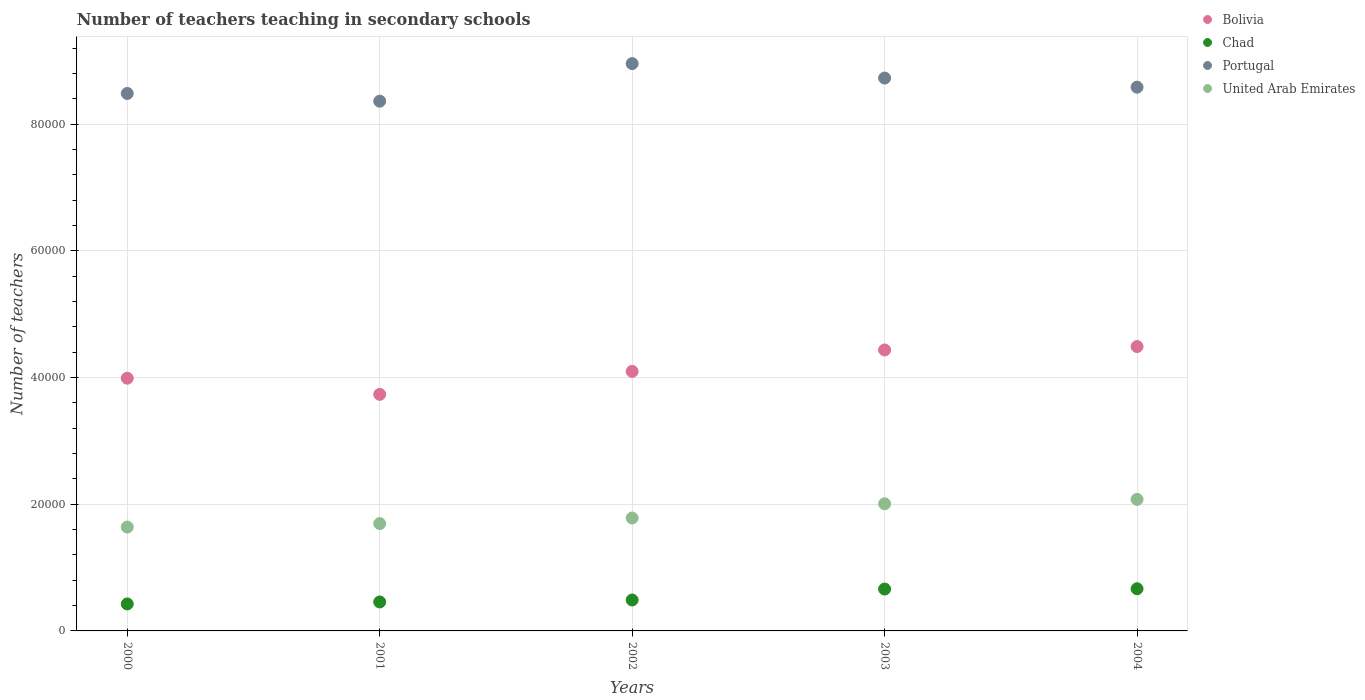How many different coloured dotlines are there?
Give a very brief answer. 4. Is the number of dotlines equal to the number of legend labels?
Ensure brevity in your answer.  Yes. What is the number of teachers teaching in secondary schools in United Arab Emirates in 2003?
Make the answer very short. 2.01e+04. Across all years, what is the maximum number of teachers teaching in secondary schools in United Arab Emirates?
Offer a very short reply. 2.08e+04. Across all years, what is the minimum number of teachers teaching in secondary schools in Chad?
Provide a short and direct response. 4260. In which year was the number of teachers teaching in secondary schools in Bolivia maximum?
Offer a terse response. 2004. In which year was the number of teachers teaching in secondary schools in Bolivia minimum?
Give a very brief answer. 2001. What is the total number of teachers teaching in secondary schools in Chad in the graph?
Ensure brevity in your answer.  2.70e+04. What is the difference between the number of teachers teaching in secondary schools in United Arab Emirates in 2000 and that in 2001?
Give a very brief answer. -551. What is the difference between the number of teachers teaching in secondary schools in United Arab Emirates in 2002 and the number of teachers teaching in secondary schools in Chad in 2000?
Offer a terse response. 1.36e+04. What is the average number of teachers teaching in secondary schools in Bolivia per year?
Offer a very short reply. 4.15e+04. In the year 2003, what is the difference between the number of teachers teaching in secondary schools in Chad and number of teachers teaching in secondary schools in Bolivia?
Offer a very short reply. -3.78e+04. In how many years, is the number of teachers teaching in secondary schools in United Arab Emirates greater than 64000?
Ensure brevity in your answer.  0. What is the ratio of the number of teachers teaching in secondary schools in Portugal in 2001 to that in 2002?
Keep it short and to the point. 0.93. What is the difference between the highest and the second highest number of teachers teaching in secondary schools in Bolivia?
Your answer should be very brief. 539. What is the difference between the highest and the lowest number of teachers teaching in secondary schools in Chad?
Ensure brevity in your answer.  2401. Is it the case that in every year, the sum of the number of teachers teaching in secondary schools in Bolivia and number of teachers teaching in secondary schools in Chad  is greater than the sum of number of teachers teaching in secondary schools in Portugal and number of teachers teaching in secondary schools in United Arab Emirates?
Give a very brief answer. No. Is it the case that in every year, the sum of the number of teachers teaching in secondary schools in Chad and number of teachers teaching in secondary schools in Bolivia  is greater than the number of teachers teaching in secondary schools in United Arab Emirates?
Provide a short and direct response. Yes. Is the number of teachers teaching in secondary schools in United Arab Emirates strictly greater than the number of teachers teaching in secondary schools in Bolivia over the years?
Your answer should be compact. No. How many dotlines are there?
Make the answer very short. 4. Are the values on the major ticks of Y-axis written in scientific E-notation?
Make the answer very short. No. Does the graph contain any zero values?
Make the answer very short. No. What is the title of the graph?
Your answer should be compact. Number of teachers teaching in secondary schools. Does "Curacao" appear as one of the legend labels in the graph?
Provide a short and direct response. No. What is the label or title of the X-axis?
Offer a very short reply. Years. What is the label or title of the Y-axis?
Your answer should be very brief. Number of teachers. What is the Number of teachers of Bolivia in 2000?
Offer a very short reply. 3.99e+04. What is the Number of teachers in Chad in 2000?
Make the answer very short. 4260. What is the Number of teachers in Portugal in 2000?
Provide a short and direct response. 8.49e+04. What is the Number of teachers of United Arab Emirates in 2000?
Ensure brevity in your answer.  1.64e+04. What is the Number of teachers in Bolivia in 2001?
Provide a succinct answer. 3.74e+04. What is the Number of teachers of Chad in 2001?
Offer a very short reply. 4572. What is the Number of teachers of Portugal in 2001?
Your answer should be very brief. 8.37e+04. What is the Number of teachers of United Arab Emirates in 2001?
Your answer should be compact. 1.70e+04. What is the Number of teachers in Bolivia in 2002?
Ensure brevity in your answer.  4.10e+04. What is the Number of teachers in Chad in 2002?
Your response must be concise. 4883. What is the Number of teachers in Portugal in 2002?
Make the answer very short. 8.96e+04. What is the Number of teachers of United Arab Emirates in 2002?
Keep it short and to the point. 1.78e+04. What is the Number of teachers in Bolivia in 2003?
Your answer should be very brief. 4.44e+04. What is the Number of teachers in Chad in 2003?
Give a very brief answer. 6613. What is the Number of teachers of Portugal in 2003?
Keep it short and to the point. 8.73e+04. What is the Number of teachers in United Arab Emirates in 2003?
Your response must be concise. 2.01e+04. What is the Number of teachers of Bolivia in 2004?
Make the answer very short. 4.49e+04. What is the Number of teachers of Chad in 2004?
Keep it short and to the point. 6661. What is the Number of teachers of Portugal in 2004?
Provide a succinct answer. 8.59e+04. What is the Number of teachers in United Arab Emirates in 2004?
Your answer should be compact. 2.08e+04. Across all years, what is the maximum Number of teachers in Bolivia?
Offer a very short reply. 4.49e+04. Across all years, what is the maximum Number of teachers of Chad?
Offer a very short reply. 6661. Across all years, what is the maximum Number of teachers of Portugal?
Provide a short and direct response. 8.96e+04. Across all years, what is the maximum Number of teachers in United Arab Emirates?
Your answer should be compact. 2.08e+04. Across all years, what is the minimum Number of teachers of Bolivia?
Ensure brevity in your answer.  3.74e+04. Across all years, what is the minimum Number of teachers of Chad?
Make the answer very short. 4260. Across all years, what is the minimum Number of teachers in Portugal?
Your answer should be compact. 8.37e+04. Across all years, what is the minimum Number of teachers in United Arab Emirates?
Make the answer very short. 1.64e+04. What is the total Number of teachers of Bolivia in the graph?
Your response must be concise. 2.08e+05. What is the total Number of teachers in Chad in the graph?
Keep it short and to the point. 2.70e+04. What is the total Number of teachers in Portugal in the graph?
Your answer should be compact. 4.31e+05. What is the total Number of teachers of United Arab Emirates in the graph?
Your answer should be very brief. 9.20e+04. What is the difference between the Number of teachers in Bolivia in 2000 and that in 2001?
Provide a short and direct response. 2550. What is the difference between the Number of teachers in Chad in 2000 and that in 2001?
Your answer should be compact. -312. What is the difference between the Number of teachers of Portugal in 2000 and that in 2001?
Your answer should be compact. 1218. What is the difference between the Number of teachers in United Arab Emirates in 2000 and that in 2001?
Provide a short and direct response. -551. What is the difference between the Number of teachers of Bolivia in 2000 and that in 2002?
Provide a succinct answer. -1079. What is the difference between the Number of teachers in Chad in 2000 and that in 2002?
Your answer should be very brief. -623. What is the difference between the Number of teachers of Portugal in 2000 and that in 2002?
Your response must be concise. -4717. What is the difference between the Number of teachers in United Arab Emirates in 2000 and that in 2002?
Offer a very short reply. -1433. What is the difference between the Number of teachers in Bolivia in 2000 and that in 2003?
Ensure brevity in your answer.  -4461. What is the difference between the Number of teachers in Chad in 2000 and that in 2003?
Give a very brief answer. -2353. What is the difference between the Number of teachers in Portugal in 2000 and that in 2003?
Your answer should be compact. -2433. What is the difference between the Number of teachers of United Arab Emirates in 2000 and that in 2003?
Provide a short and direct response. -3679. What is the difference between the Number of teachers in Bolivia in 2000 and that in 2004?
Your answer should be very brief. -5000. What is the difference between the Number of teachers in Chad in 2000 and that in 2004?
Offer a terse response. -2401. What is the difference between the Number of teachers of Portugal in 2000 and that in 2004?
Provide a succinct answer. -989. What is the difference between the Number of teachers in United Arab Emirates in 2000 and that in 2004?
Your answer should be compact. -4369. What is the difference between the Number of teachers of Bolivia in 2001 and that in 2002?
Keep it short and to the point. -3629. What is the difference between the Number of teachers in Chad in 2001 and that in 2002?
Keep it short and to the point. -311. What is the difference between the Number of teachers of Portugal in 2001 and that in 2002?
Your response must be concise. -5935. What is the difference between the Number of teachers in United Arab Emirates in 2001 and that in 2002?
Keep it short and to the point. -882. What is the difference between the Number of teachers of Bolivia in 2001 and that in 2003?
Your answer should be compact. -7011. What is the difference between the Number of teachers of Chad in 2001 and that in 2003?
Provide a short and direct response. -2041. What is the difference between the Number of teachers of Portugal in 2001 and that in 2003?
Offer a very short reply. -3651. What is the difference between the Number of teachers of United Arab Emirates in 2001 and that in 2003?
Your response must be concise. -3128. What is the difference between the Number of teachers of Bolivia in 2001 and that in 2004?
Offer a terse response. -7550. What is the difference between the Number of teachers of Chad in 2001 and that in 2004?
Offer a very short reply. -2089. What is the difference between the Number of teachers of Portugal in 2001 and that in 2004?
Keep it short and to the point. -2207. What is the difference between the Number of teachers in United Arab Emirates in 2001 and that in 2004?
Provide a succinct answer. -3818. What is the difference between the Number of teachers of Bolivia in 2002 and that in 2003?
Your answer should be compact. -3382. What is the difference between the Number of teachers of Chad in 2002 and that in 2003?
Provide a short and direct response. -1730. What is the difference between the Number of teachers of Portugal in 2002 and that in 2003?
Give a very brief answer. 2284. What is the difference between the Number of teachers in United Arab Emirates in 2002 and that in 2003?
Offer a very short reply. -2246. What is the difference between the Number of teachers in Bolivia in 2002 and that in 2004?
Your answer should be very brief. -3921. What is the difference between the Number of teachers of Chad in 2002 and that in 2004?
Offer a terse response. -1778. What is the difference between the Number of teachers in Portugal in 2002 and that in 2004?
Provide a short and direct response. 3728. What is the difference between the Number of teachers in United Arab Emirates in 2002 and that in 2004?
Keep it short and to the point. -2936. What is the difference between the Number of teachers of Bolivia in 2003 and that in 2004?
Offer a very short reply. -539. What is the difference between the Number of teachers in Chad in 2003 and that in 2004?
Your response must be concise. -48. What is the difference between the Number of teachers of Portugal in 2003 and that in 2004?
Your answer should be compact. 1444. What is the difference between the Number of teachers in United Arab Emirates in 2003 and that in 2004?
Your answer should be compact. -690. What is the difference between the Number of teachers in Bolivia in 2000 and the Number of teachers in Chad in 2001?
Offer a very short reply. 3.53e+04. What is the difference between the Number of teachers of Bolivia in 2000 and the Number of teachers of Portugal in 2001?
Offer a very short reply. -4.37e+04. What is the difference between the Number of teachers in Bolivia in 2000 and the Number of teachers in United Arab Emirates in 2001?
Your response must be concise. 2.30e+04. What is the difference between the Number of teachers in Chad in 2000 and the Number of teachers in Portugal in 2001?
Your response must be concise. -7.94e+04. What is the difference between the Number of teachers in Chad in 2000 and the Number of teachers in United Arab Emirates in 2001?
Offer a terse response. -1.27e+04. What is the difference between the Number of teachers in Portugal in 2000 and the Number of teachers in United Arab Emirates in 2001?
Give a very brief answer. 6.79e+04. What is the difference between the Number of teachers of Bolivia in 2000 and the Number of teachers of Chad in 2002?
Your answer should be compact. 3.50e+04. What is the difference between the Number of teachers in Bolivia in 2000 and the Number of teachers in Portugal in 2002?
Your answer should be compact. -4.97e+04. What is the difference between the Number of teachers in Bolivia in 2000 and the Number of teachers in United Arab Emirates in 2002?
Your answer should be compact. 2.21e+04. What is the difference between the Number of teachers in Chad in 2000 and the Number of teachers in Portugal in 2002?
Give a very brief answer. -8.53e+04. What is the difference between the Number of teachers of Chad in 2000 and the Number of teachers of United Arab Emirates in 2002?
Provide a short and direct response. -1.36e+04. What is the difference between the Number of teachers of Portugal in 2000 and the Number of teachers of United Arab Emirates in 2002?
Offer a terse response. 6.70e+04. What is the difference between the Number of teachers of Bolivia in 2000 and the Number of teachers of Chad in 2003?
Give a very brief answer. 3.33e+04. What is the difference between the Number of teachers of Bolivia in 2000 and the Number of teachers of Portugal in 2003?
Your answer should be compact. -4.74e+04. What is the difference between the Number of teachers of Bolivia in 2000 and the Number of teachers of United Arab Emirates in 2003?
Make the answer very short. 1.98e+04. What is the difference between the Number of teachers of Chad in 2000 and the Number of teachers of Portugal in 2003?
Make the answer very short. -8.30e+04. What is the difference between the Number of teachers of Chad in 2000 and the Number of teachers of United Arab Emirates in 2003?
Ensure brevity in your answer.  -1.58e+04. What is the difference between the Number of teachers of Portugal in 2000 and the Number of teachers of United Arab Emirates in 2003?
Your answer should be compact. 6.48e+04. What is the difference between the Number of teachers in Bolivia in 2000 and the Number of teachers in Chad in 2004?
Your response must be concise. 3.32e+04. What is the difference between the Number of teachers of Bolivia in 2000 and the Number of teachers of Portugal in 2004?
Your answer should be very brief. -4.60e+04. What is the difference between the Number of teachers of Bolivia in 2000 and the Number of teachers of United Arab Emirates in 2004?
Ensure brevity in your answer.  1.91e+04. What is the difference between the Number of teachers in Chad in 2000 and the Number of teachers in Portugal in 2004?
Offer a very short reply. -8.16e+04. What is the difference between the Number of teachers in Chad in 2000 and the Number of teachers in United Arab Emirates in 2004?
Your answer should be compact. -1.65e+04. What is the difference between the Number of teachers of Portugal in 2000 and the Number of teachers of United Arab Emirates in 2004?
Keep it short and to the point. 6.41e+04. What is the difference between the Number of teachers in Bolivia in 2001 and the Number of teachers in Chad in 2002?
Offer a terse response. 3.25e+04. What is the difference between the Number of teachers in Bolivia in 2001 and the Number of teachers in Portugal in 2002?
Your answer should be very brief. -5.22e+04. What is the difference between the Number of teachers of Bolivia in 2001 and the Number of teachers of United Arab Emirates in 2002?
Ensure brevity in your answer.  1.95e+04. What is the difference between the Number of teachers of Chad in 2001 and the Number of teachers of Portugal in 2002?
Your answer should be very brief. -8.50e+04. What is the difference between the Number of teachers in Chad in 2001 and the Number of teachers in United Arab Emirates in 2002?
Provide a short and direct response. -1.33e+04. What is the difference between the Number of teachers in Portugal in 2001 and the Number of teachers in United Arab Emirates in 2002?
Offer a very short reply. 6.58e+04. What is the difference between the Number of teachers of Bolivia in 2001 and the Number of teachers of Chad in 2003?
Provide a succinct answer. 3.07e+04. What is the difference between the Number of teachers in Bolivia in 2001 and the Number of teachers in Portugal in 2003?
Provide a succinct answer. -4.99e+04. What is the difference between the Number of teachers in Bolivia in 2001 and the Number of teachers in United Arab Emirates in 2003?
Offer a terse response. 1.73e+04. What is the difference between the Number of teachers of Chad in 2001 and the Number of teachers of Portugal in 2003?
Provide a succinct answer. -8.27e+04. What is the difference between the Number of teachers in Chad in 2001 and the Number of teachers in United Arab Emirates in 2003?
Provide a short and direct response. -1.55e+04. What is the difference between the Number of teachers in Portugal in 2001 and the Number of teachers in United Arab Emirates in 2003?
Keep it short and to the point. 6.36e+04. What is the difference between the Number of teachers in Bolivia in 2001 and the Number of teachers in Chad in 2004?
Provide a short and direct response. 3.07e+04. What is the difference between the Number of teachers in Bolivia in 2001 and the Number of teachers in Portugal in 2004?
Your answer should be compact. -4.85e+04. What is the difference between the Number of teachers of Bolivia in 2001 and the Number of teachers of United Arab Emirates in 2004?
Keep it short and to the point. 1.66e+04. What is the difference between the Number of teachers in Chad in 2001 and the Number of teachers in Portugal in 2004?
Provide a short and direct response. -8.13e+04. What is the difference between the Number of teachers of Chad in 2001 and the Number of teachers of United Arab Emirates in 2004?
Give a very brief answer. -1.62e+04. What is the difference between the Number of teachers of Portugal in 2001 and the Number of teachers of United Arab Emirates in 2004?
Keep it short and to the point. 6.29e+04. What is the difference between the Number of teachers in Bolivia in 2002 and the Number of teachers in Chad in 2003?
Give a very brief answer. 3.44e+04. What is the difference between the Number of teachers of Bolivia in 2002 and the Number of teachers of Portugal in 2003?
Offer a very short reply. -4.63e+04. What is the difference between the Number of teachers in Bolivia in 2002 and the Number of teachers in United Arab Emirates in 2003?
Provide a succinct answer. 2.09e+04. What is the difference between the Number of teachers of Chad in 2002 and the Number of teachers of Portugal in 2003?
Offer a terse response. -8.24e+04. What is the difference between the Number of teachers in Chad in 2002 and the Number of teachers in United Arab Emirates in 2003?
Make the answer very short. -1.52e+04. What is the difference between the Number of teachers in Portugal in 2002 and the Number of teachers in United Arab Emirates in 2003?
Your answer should be compact. 6.95e+04. What is the difference between the Number of teachers of Bolivia in 2002 and the Number of teachers of Chad in 2004?
Offer a very short reply. 3.43e+04. What is the difference between the Number of teachers in Bolivia in 2002 and the Number of teachers in Portugal in 2004?
Offer a very short reply. -4.49e+04. What is the difference between the Number of teachers in Bolivia in 2002 and the Number of teachers in United Arab Emirates in 2004?
Make the answer very short. 2.02e+04. What is the difference between the Number of teachers in Chad in 2002 and the Number of teachers in Portugal in 2004?
Your answer should be very brief. -8.10e+04. What is the difference between the Number of teachers in Chad in 2002 and the Number of teachers in United Arab Emirates in 2004?
Provide a short and direct response. -1.59e+04. What is the difference between the Number of teachers of Portugal in 2002 and the Number of teachers of United Arab Emirates in 2004?
Offer a terse response. 6.88e+04. What is the difference between the Number of teachers of Bolivia in 2003 and the Number of teachers of Chad in 2004?
Ensure brevity in your answer.  3.77e+04. What is the difference between the Number of teachers in Bolivia in 2003 and the Number of teachers in Portugal in 2004?
Your answer should be compact. -4.15e+04. What is the difference between the Number of teachers of Bolivia in 2003 and the Number of teachers of United Arab Emirates in 2004?
Give a very brief answer. 2.36e+04. What is the difference between the Number of teachers of Chad in 2003 and the Number of teachers of Portugal in 2004?
Your response must be concise. -7.92e+04. What is the difference between the Number of teachers of Chad in 2003 and the Number of teachers of United Arab Emirates in 2004?
Make the answer very short. -1.42e+04. What is the difference between the Number of teachers of Portugal in 2003 and the Number of teachers of United Arab Emirates in 2004?
Ensure brevity in your answer.  6.65e+04. What is the average Number of teachers in Bolivia per year?
Ensure brevity in your answer.  4.15e+04. What is the average Number of teachers of Chad per year?
Make the answer very short. 5397.8. What is the average Number of teachers of Portugal per year?
Make the answer very short. 8.63e+04. What is the average Number of teachers of United Arab Emirates per year?
Offer a very short reply. 1.84e+04. In the year 2000, what is the difference between the Number of teachers in Bolivia and Number of teachers in Chad?
Your answer should be compact. 3.56e+04. In the year 2000, what is the difference between the Number of teachers of Bolivia and Number of teachers of Portugal?
Offer a very short reply. -4.50e+04. In the year 2000, what is the difference between the Number of teachers of Bolivia and Number of teachers of United Arab Emirates?
Your answer should be compact. 2.35e+04. In the year 2000, what is the difference between the Number of teachers of Chad and Number of teachers of Portugal?
Ensure brevity in your answer.  -8.06e+04. In the year 2000, what is the difference between the Number of teachers in Chad and Number of teachers in United Arab Emirates?
Give a very brief answer. -1.21e+04. In the year 2000, what is the difference between the Number of teachers of Portugal and Number of teachers of United Arab Emirates?
Make the answer very short. 6.85e+04. In the year 2001, what is the difference between the Number of teachers in Bolivia and Number of teachers in Chad?
Your response must be concise. 3.28e+04. In the year 2001, what is the difference between the Number of teachers of Bolivia and Number of teachers of Portugal?
Make the answer very short. -4.63e+04. In the year 2001, what is the difference between the Number of teachers in Bolivia and Number of teachers in United Arab Emirates?
Make the answer very short. 2.04e+04. In the year 2001, what is the difference between the Number of teachers in Chad and Number of teachers in Portugal?
Provide a short and direct response. -7.91e+04. In the year 2001, what is the difference between the Number of teachers of Chad and Number of teachers of United Arab Emirates?
Offer a very short reply. -1.24e+04. In the year 2001, what is the difference between the Number of teachers in Portugal and Number of teachers in United Arab Emirates?
Provide a succinct answer. 6.67e+04. In the year 2002, what is the difference between the Number of teachers in Bolivia and Number of teachers in Chad?
Your answer should be very brief. 3.61e+04. In the year 2002, what is the difference between the Number of teachers in Bolivia and Number of teachers in Portugal?
Provide a succinct answer. -4.86e+04. In the year 2002, what is the difference between the Number of teachers in Bolivia and Number of teachers in United Arab Emirates?
Offer a very short reply. 2.32e+04. In the year 2002, what is the difference between the Number of teachers in Chad and Number of teachers in Portugal?
Keep it short and to the point. -8.47e+04. In the year 2002, what is the difference between the Number of teachers in Chad and Number of teachers in United Arab Emirates?
Give a very brief answer. -1.29e+04. In the year 2002, what is the difference between the Number of teachers in Portugal and Number of teachers in United Arab Emirates?
Keep it short and to the point. 7.18e+04. In the year 2003, what is the difference between the Number of teachers in Bolivia and Number of teachers in Chad?
Provide a succinct answer. 3.78e+04. In the year 2003, what is the difference between the Number of teachers in Bolivia and Number of teachers in Portugal?
Provide a succinct answer. -4.29e+04. In the year 2003, what is the difference between the Number of teachers in Bolivia and Number of teachers in United Arab Emirates?
Provide a short and direct response. 2.43e+04. In the year 2003, what is the difference between the Number of teachers of Chad and Number of teachers of Portugal?
Give a very brief answer. -8.07e+04. In the year 2003, what is the difference between the Number of teachers in Chad and Number of teachers in United Arab Emirates?
Your answer should be compact. -1.35e+04. In the year 2003, what is the difference between the Number of teachers in Portugal and Number of teachers in United Arab Emirates?
Provide a short and direct response. 6.72e+04. In the year 2004, what is the difference between the Number of teachers of Bolivia and Number of teachers of Chad?
Your answer should be very brief. 3.82e+04. In the year 2004, what is the difference between the Number of teachers in Bolivia and Number of teachers in Portugal?
Offer a terse response. -4.10e+04. In the year 2004, what is the difference between the Number of teachers of Bolivia and Number of teachers of United Arab Emirates?
Provide a short and direct response. 2.41e+04. In the year 2004, what is the difference between the Number of teachers in Chad and Number of teachers in Portugal?
Give a very brief answer. -7.92e+04. In the year 2004, what is the difference between the Number of teachers in Chad and Number of teachers in United Arab Emirates?
Offer a very short reply. -1.41e+04. In the year 2004, what is the difference between the Number of teachers of Portugal and Number of teachers of United Arab Emirates?
Ensure brevity in your answer.  6.51e+04. What is the ratio of the Number of teachers of Bolivia in 2000 to that in 2001?
Give a very brief answer. 1.07. What is the ratio of the Number of teachers of Chad in 2000 to that in 2001?
Ensure brevity in your answer.  0.93. What is the ratio of the Number of teachers in Portugal in 2000 to that in 2001?
Offer a very short reply. 1.01. What is the ratio of the Number of teachers of United Arab Emirates in 2000 to that in 2001?
Provide a short and direct response. 0.97. What is the ratio of the Number of teachers in Bolivia in 2000 to that in 2002?
Your answer should be very brief. 0.97. What is the ratio of the Number of teachers of Chad in 2000 to that in 2002?
Offer a very short reply. 0.87. What is the ratio of the Number of teachers of Portugal in 2000 to that in 2002?
Offer a very short reply. 0.95. What is the ratio of the Number of teachers in United Arab Emirates in 2000 to that in 2002?
Make the answer very short. 0.92. What is the ratio of the Number of teachers in Bolivia in 2000 to that in 2003?
Your response must be concise. 0.9. What is the ratio of the Number of teachers in Chad in 2000 to that in 2003?
Your answer should be compact. 0.64. What is the ratio of the Number of teachers of Portugal in 2000 to that in 2003?
Provide a succinct answer. 0.97. What is the ratio of the Number of teachers in United Arab Emirates in 2000 to that in 2003?
Keep it short and to the point. 0.82. What is the ratio of the Number of teachers in Bolivia in 2000 to that in 2004?
Provide a short and direct response. 0.89. What is the ratio of the Number of teachers in Chad in 2000 to that in 2004?
Keep it short and to the point. 0.64. What is the ratio of the Number of teachers in Portugal in 2000 to that in 2004?
Provide a succinct answer. 0.99. What is the ratio of the Number of teachers in United Arab Emirates in 2000 to that in 2004?
Ensure brevity in your answer.  0.79. What is the ratio of the Number of teachers in Bolivia in 2001 to that in 2002?
Your response must be concise. 0.91. What is the ratio of the Number of teachers of Chad in 2001 to that in 2002?
Your answer should be very brief. 0.94. What is the ratio of the Number of teachers in Portugal in 2001 to that in 2002?
Your answer should be very brief. 0.93. What is the ratio of the Number of teachers of United Arab Emirates in 2001 to that in 2002?
Provide a succinct answer. 0.95. What is the ratio of the Number of teachers in Bolivia in 2001 to that in 2003?
Your answer should be very brief. 0.84. What is the ratio of the Number of teachers in Chad in 2001 to that in 2003?
Offer a very short reply. 0.69. What is the ratio of the Number of teachers of Portugal in 2001 to that in 2003?
Keep it short and to the point. 0.96. What is the ratio of the Number of teachers in United Arab Emirates in 2001 to that in 2003?
Offer a very short reply. 0.84. What is the ratio of the Number of teachers in Bolivia in 2001 to that in 2004?
Your response must be concise. 0.83. What is the ratio of the Number of teachers of Chad in 2001 to that in 2004?
Make the answer very short. 0.69. What is the ratio of the Number of teachers in Portugal in 2001 to that in 2004?
Provide a succinct answer. 0.97. What is the ratio of the Number of teachers of United Arab Emirates in 2001 to that in 2004?
Make the answer very short. 0.82. What is the ratio of the Number of teachers in Bolivia in 2002 to that in 2003?
Keep it short and to the point. 0.92. What is the ratio of the Number of teachers in Chad in 2002 to that in 2003?
Provide a short and direct response. 0.74. What is the ratio of the Number of teachers in Portugal in 2002 to that in 2003?
Your response must be concise. 1.03. What is the ratio of the Number of teachers in United Arab Emirates in 2002 to that in 2003?
Ensure brevity in your answer.  0.89. What is the ratio of the Number of teachers of Bolivia in 2002 to that in 2004?
Give a very brief answer. 0.91. What is the ratio of the Number of teachers of Chad in 2002 to that in 2004?
Provide a succinct answer. 0.73. What is the ratio of the Number of teachers of Portugal in 2002 to that in 2004?
Give a very brief answer. 1.04. What is the ratio of the Number of teachers of United Arab Emirates in 2002 to that in 2004?
Offer a very short reply. 0.86. What is the ratio of the Number of teachers of Bolivia in 2003 to that in 2004?
Make the answer very short. 0.99. What is the ratio of the Number of teachers of Chad in 2003 to that in 2004?
Give a very brief answer. 0.99. What is the ratio of the Number of teachers in Portugal in 2003 to that in 2004?
Keep it short and to the point. 1.02. What is the ratio of the Number of teachers of United Arab Emirates in 2003 to that in 2004?
Your answer should be very brief. 0.97. What is the difference between the highest and the second highest Number of teachers of Bolivia?
Provide a short and direct response. 539. What is the difference between the highest and the second highest Number of teachers of Portugal?
Your answer should be very brief. 2284. What is the difference between the highest and the second highest Number of teachers of United Arab Emirates?
Ensure brevity in your answer.  690. What is the difference between the highest and the lowest Number of teachers of Bolivia?
Make the answer very short. 7550. What is the difference between the highest and the lowest Number of teachers in Chad?
Ensure brevity in your answer.  2401. What is the difference between the highest and the lowest Number of teachers in Portugal?
Make the answer very short. 5935. What is the difference between the highest and the lowest Number of teachers in United Arab Emirates?
Your response must be concise. 4369. 